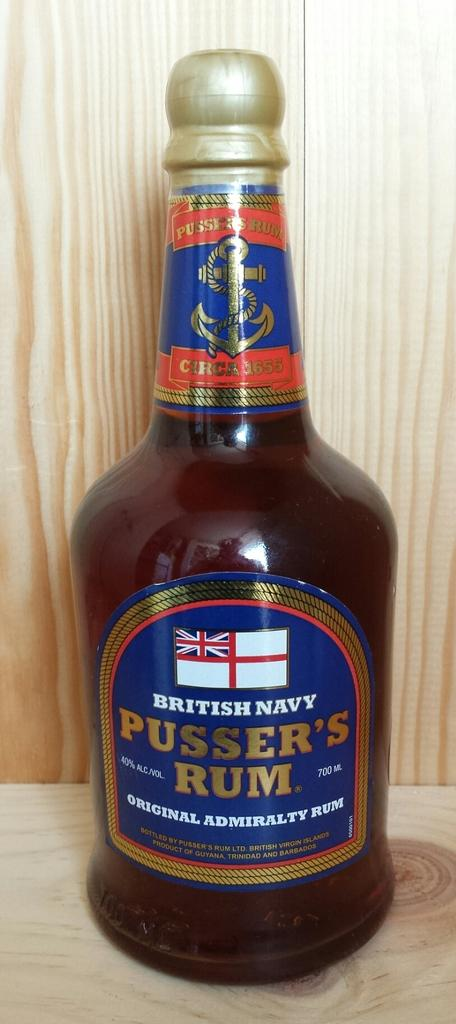<image>
Relay a brief, clear account of the picture shown. Bottle of British Navy Pusser's Rum placed on a wooden platform. 